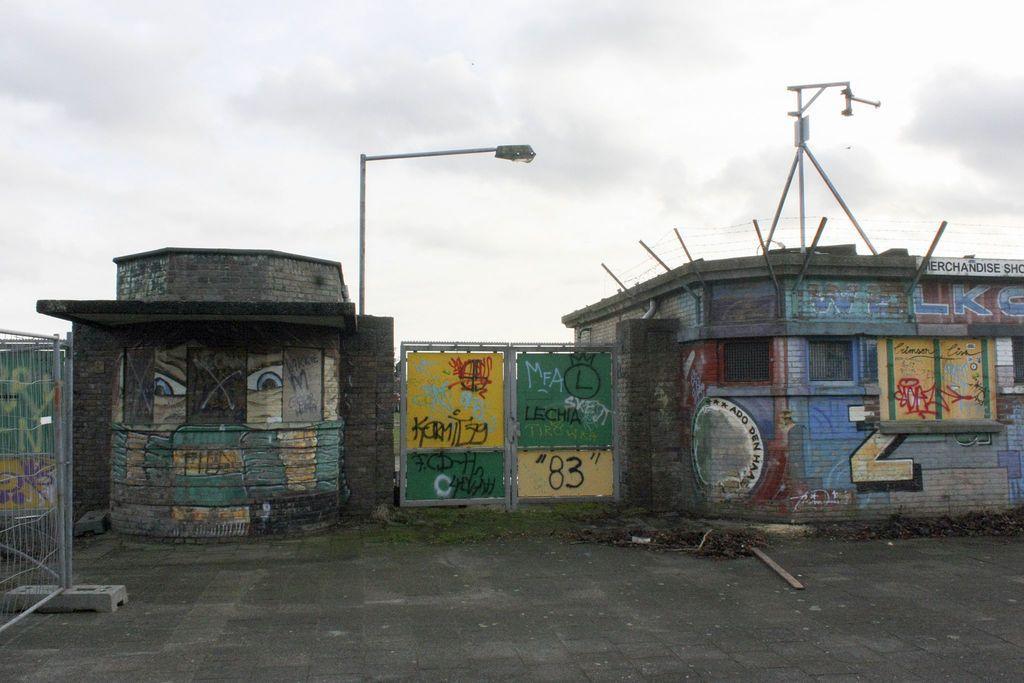Describe this image in one or two sentences. In the picture we can see two small houses on it and we can see many paintings and in the middle of it, we can see a gate, on the gate also we can see the painting and near the house we can see a pole with a light and a railing inside the house and in the background we can see a sky with clouds. 